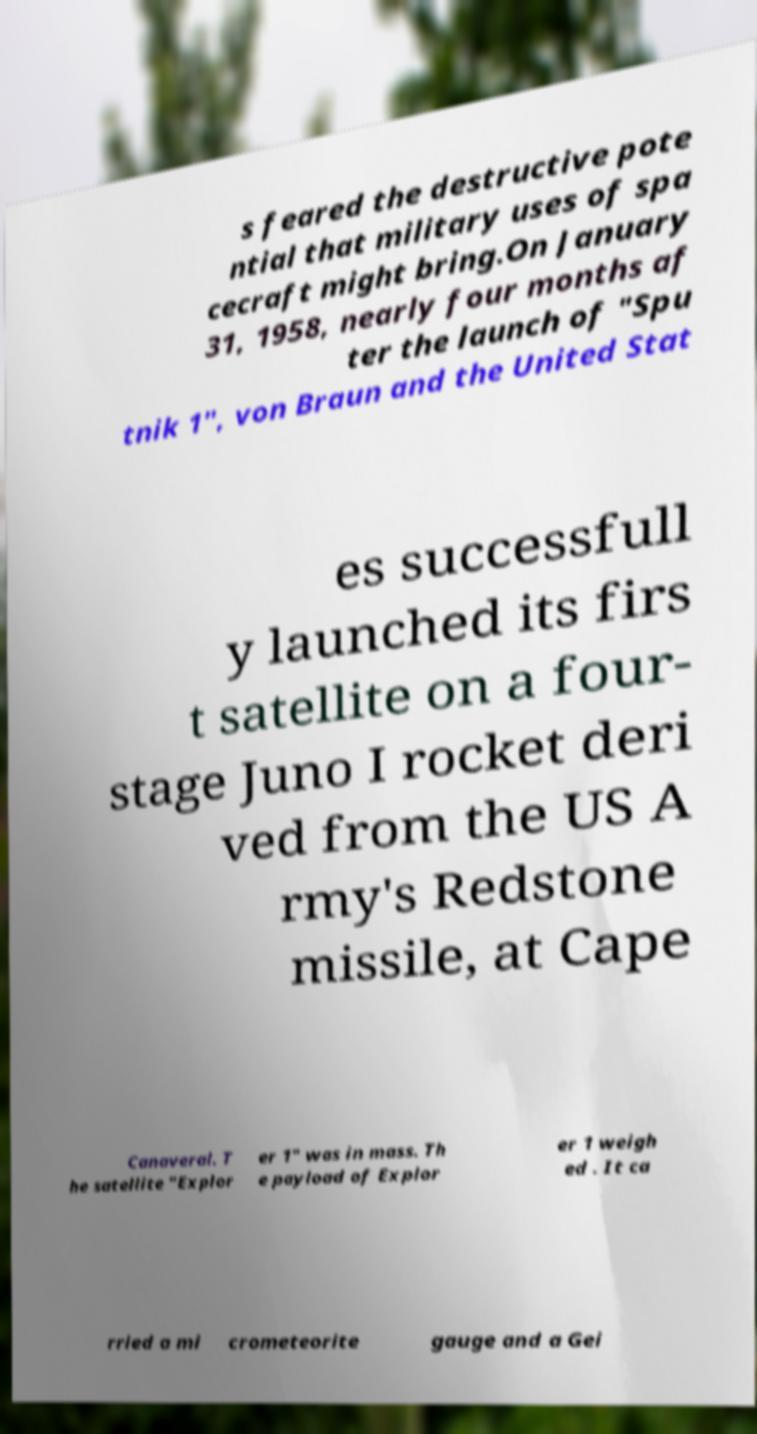Please identify and transcribe the text found in this image. s feared the destructive pote ntial that military uses of spa cecraft might bring.On January 31, 1958, nearly four months af ter the launch of "Spu tnik 1", von Braun and the United Stat es successfull y launched its firs t satellite on a four- stage Juno I rocket deri ved from the US A rmy's Redstone missile, at Cape Canaveral. T he satellite "Explor er 1" was in mass. Th e payload of Explor er 1 weigh ed . It ca rried a mi crometeorite gauge and a Gei 